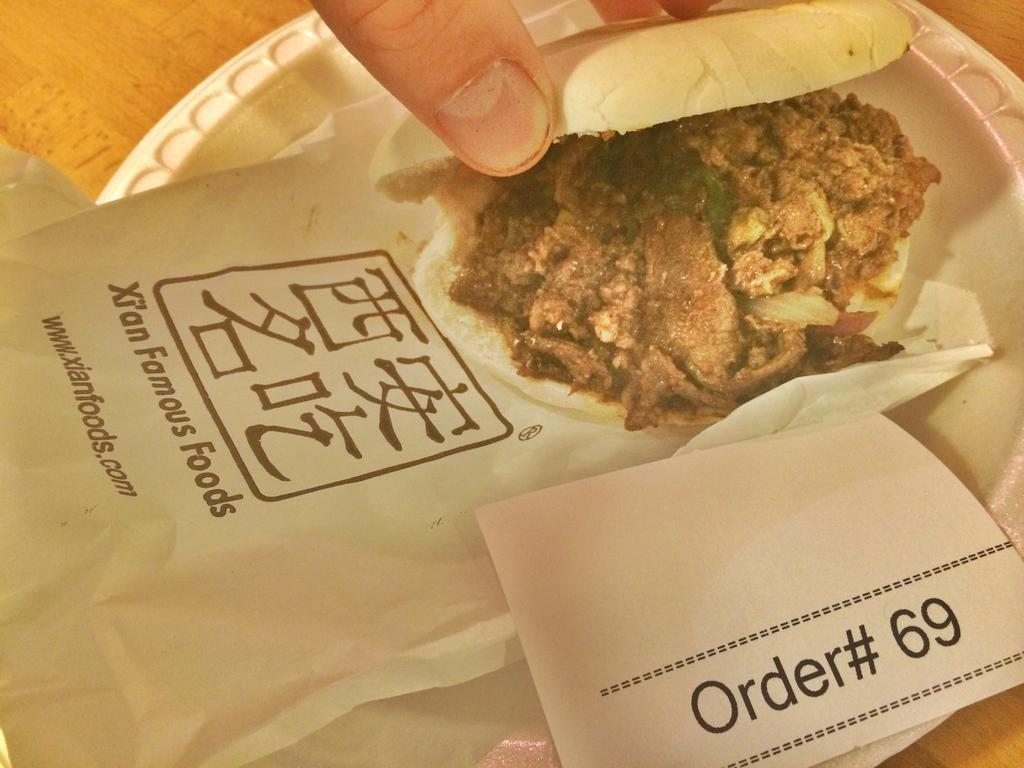What is the main object in the center of the image? There is a plate in the center of the image. What is on the plate? There is a small burger on the plate. Whose fingers are visible at the top side of the image? The fingers are not identified in the image, so we cannot determine whose fingers they are. What type of steel is used to make the gun in the image? There is no gun present in the image, so we cannot determine the type of steel used to make it. 